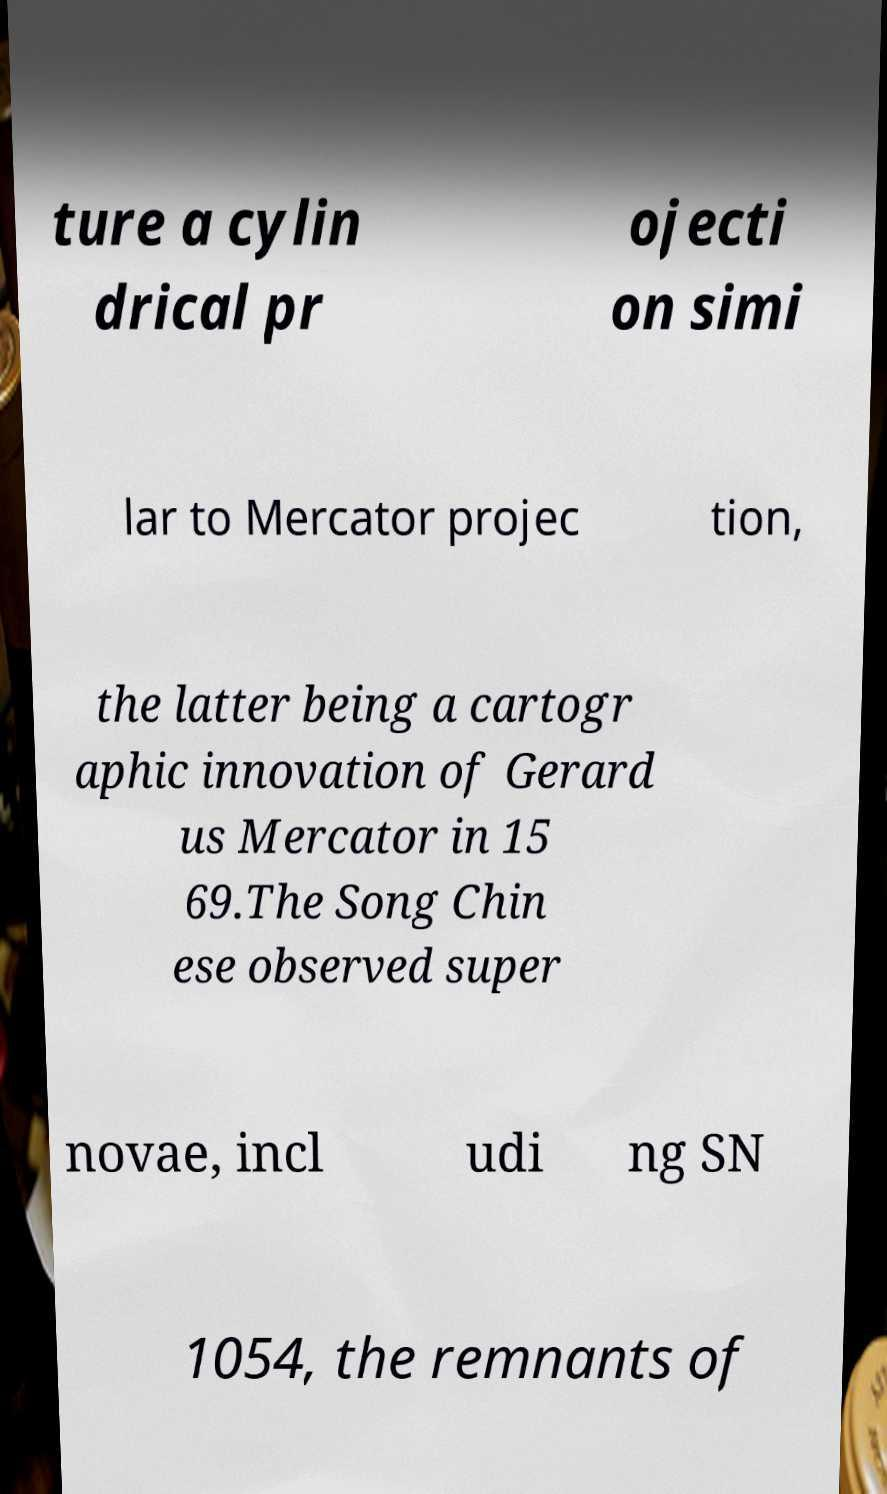Could you assist in decoding the text presented in this image and type it out clearly? ture a cylin drical pr ojecti on simi lar to Mercator projec tion, the latter being a cartogr aphic innovation of Gerard us Mercator in 15 69.The Song Chin ese observed super novae, incl udi ng SN 1054, the remnants of 